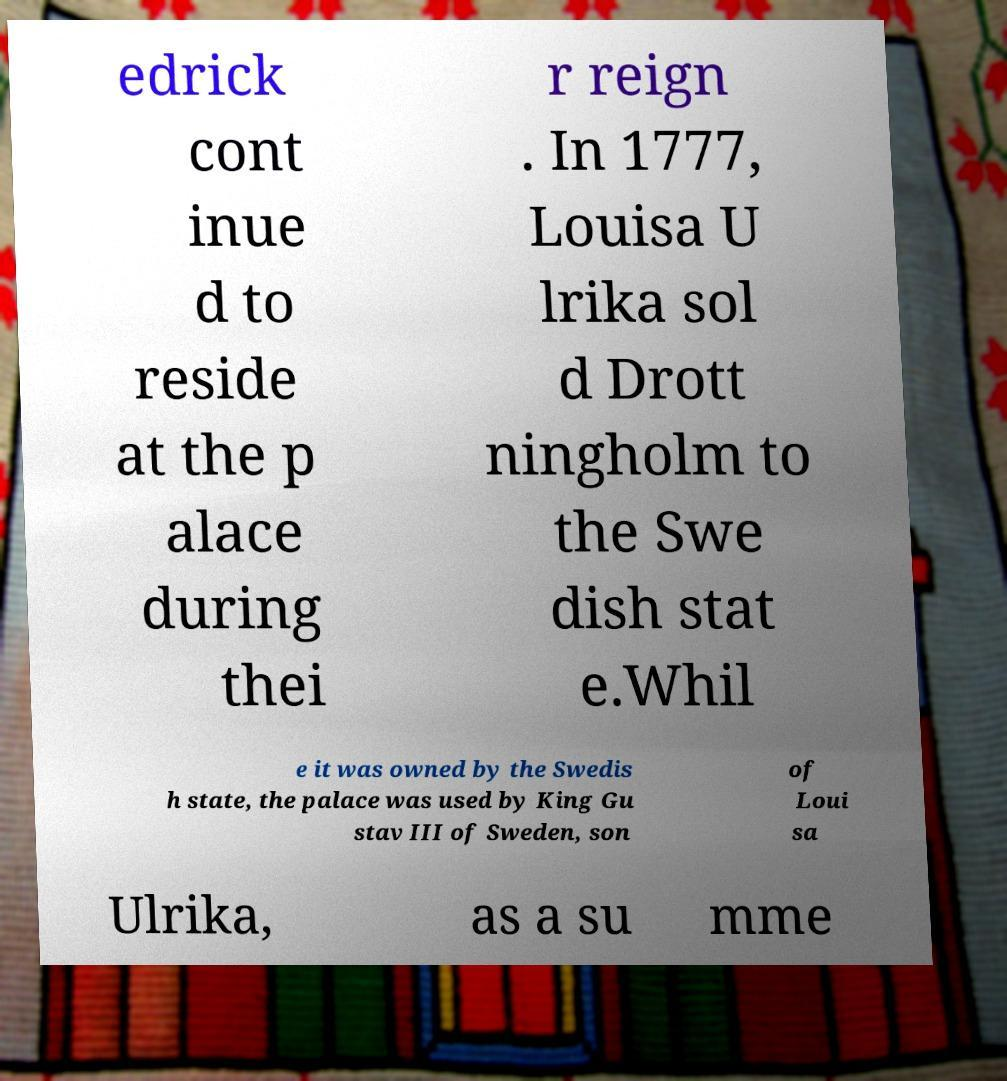Could you extract and type out the text from this image? edrick cont inue d to reside at the p alace during thei r reign . In 1777, Louisa U lrika sol d Drott ningholm to the Swe dish stat e.Whil e it was owned by the Swedis h state, the palace was used by King Gu stav III of Sweden, son of Loui sa Ulrika, as a su mme 